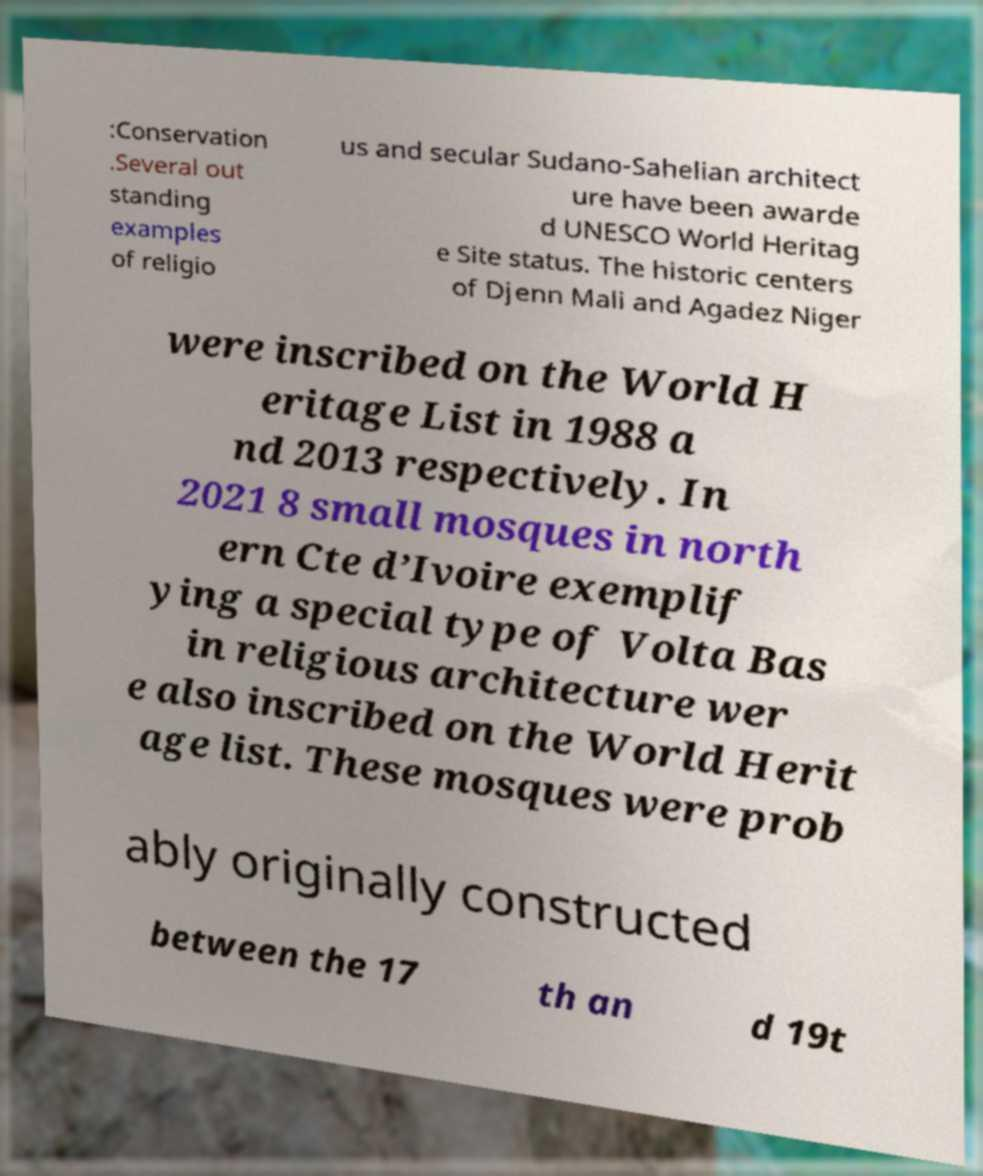What messages or text are displayed in this image? I need them in a readable, typed format. :Conservation .Several out standing examples of religio us and secular Sudano-Sahelian architect ure have been awarde d UNESCO World Heritag e Site status. The historic centers of Djenn Mali and Agadez Niger were inscribed on the World H eritage List in 1988 a nd 2013 respectively. In 2021 8 small mosques in north ern Cte d’Ivoire exemplif ying a special type of Volta Bas in religious architecture wer e also inscribed on the World Herit age list. These mosques were prob ably originally constructed between the 17 th an d 19t 